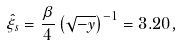<formula> <loc_0><loc_0><loc_500><loc_500>\hat { \xi } _ { s } = \frac { \beta } { 4 } \left ( \sqrt { - y } \right ) ^ { - 1 } = 3 . 2 0 ,</formula> 